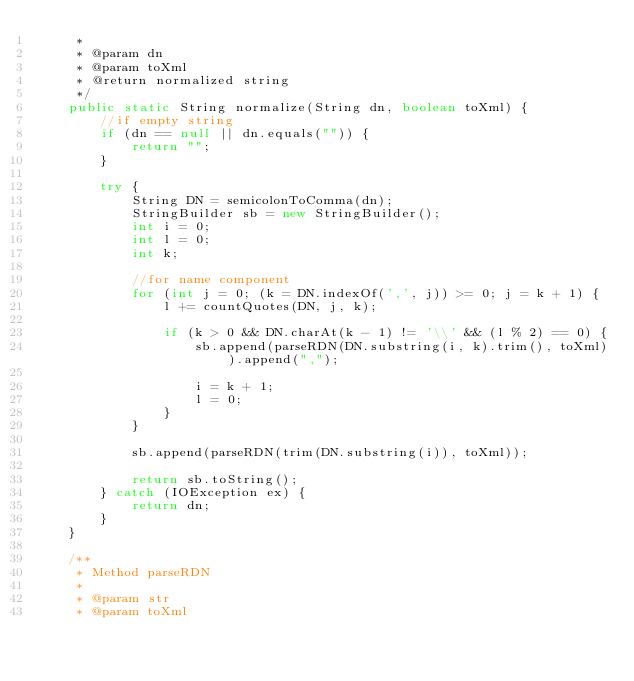Convert code to text. <code><loc_0><loc_0><loc_500><loc_500><_Java_>     *
     * @param dn
     * @param toXml
     * @return normalized string
     */
    public static String normalize(String dn, boolean toXml) {
        //if empty string
        if (dn == null || dn.equals("")) {
            return "";
        }

        try {
            String DN = semicolonToComma(dn);
            StringBuilder sb = new StringBuilder();
            int i = 0;
            int l = 0;
            int k;

            //for name component
            for (int j = 0; (k = DN.indexOf(',', j)) >= 0; j = k + 1) {
                l += countQuotes(DN, j, k);

                if (k > 0 && DN.charAt(k - 1) != '\\' && (l % 2) == 0) {
                    sb.append(parseRDN(DN.substring(i, k).trim(), toXml)).append(",");

                    i = k + 1;
                    l = 0;
                }
            }

            sb.append(parseRDN(trim(DN.substring(i)), toXml));

            return sb.toString();
        } catch (IOException ex) {
            return dn;
        }
    }

    /**
     * Method parseRDN
     *
     * @param str
     * @param toXml</code> 